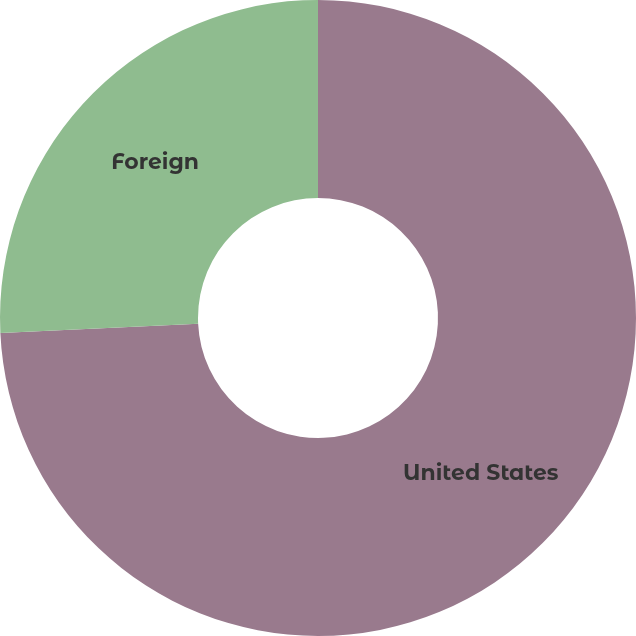Convert chart to OTSL. <chart><loc_0><loc_0><loc_500><loc_500><pie_chart><fcel>United States<fcel>Foreign<nl><fcel>74.25%<fcel>25.75%<nl></chart> 